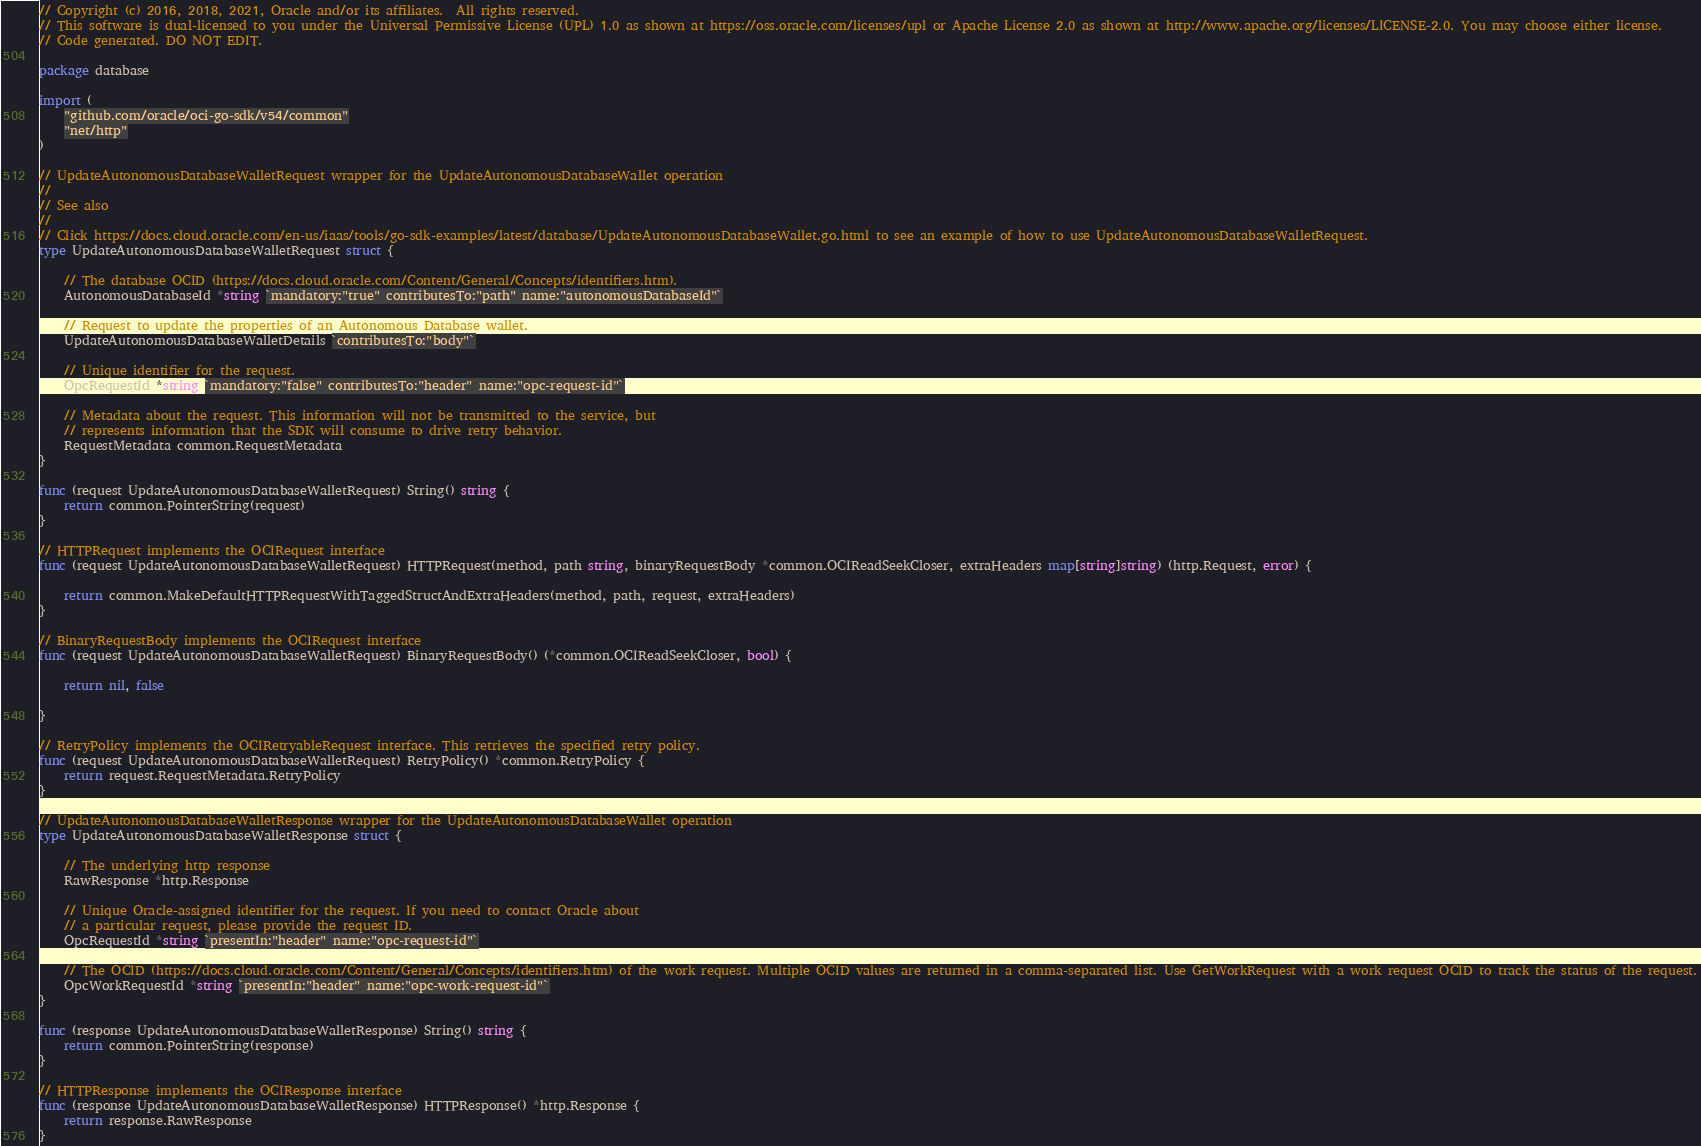Convert code to text. <code><loc_0><loc_0><loc_500><loc_500><_Go_>// Copyright (c) 2016, 2018, 2021, Oracle and/or its affiliates.  All rights reserved.
// This software is dual-licensed to you under the Universal Permissive License (UPL) 1.0 as shown at https://oss.oracle.com/licenses/upl or Apache License 2.0 as shown at http://www.apache.org/licenses/LICENSE-2.0. You may choose either license.
// Code generated. DO NOT EDIT.

package database

import (
	"github.com/oracle/oci-go-sdk/v54/common"
	"net/http"
)

// UpdateAutonomousDatabaseWalletRequest wrapper for the UpdateAutonomousDatabaseWallet operation
//
// See also
//
// Click https://docs.cloud.oracle.com/en-us/iaas/tools/go-sdk-examples/latest/database/UpdateAutonomousDatabaseWallet.go.html to see an example of how to use UpdateAutonomousDatabaseWalletRequest.
type UpdateAutonomousDatabaseWalletRequest struct {

	// The database OCID (https://docs.cloud.oracle.com/Content/General/Concepts/identifiers.htm).
	AutonomousDatabaseId *string `mandatory:"true" contributesTo:"path" name:"autonomousDatabaseId"`

	// Request to update the properties of an Autonomous Database wallet.
	UpdateAutonomousDatabaseWalletDetails `contributesTo:"body"`

	// Unique identifier for the request.
	OpcRequestId *string `mandatory:"false" contributesTo:"header" name:"opc-request-id"`

	// Metadata about the request. This information will not be transmitted to the service, but
	// represents information that the SDK will consume to drive retry behavior.
	RequestMetadata common.RequestMetadata
}

func (request UpdateAutonomousDatabaseWalletRequest) String() string {
	return common.PointerString(request)
}

// HTTPRequest implements the OCIRequest interface
func (request UpdateAutonomousDatabaseWalletRequest) HTTPRequest(method, path string, binaryRequestBody *common.OCIReadSeekCloser, extraHeaders map[string]string) (http.Request, error) {

	return common.MakeDefaultHTTPRequestWithTaggedStructAndExtraHeaders(method, path, request, extraHeaders)
}

// BinaryRequestBody implements the OCIRequest interface
func (request UpdateAutonomousDatabaseWalletRequest) BinaryRequestBody() (*common.OCIReadSeekCloser, bool) {

	return nil, false

}

// RetryPolicy implements the OCIRetryableRequest interface. This retrieves the specified retry policy.
func (request UpdateAutonomousDatabaseWalletRequest) RetryPolicy() *common.RetryPolicy {
	return request.RequestMetadata.RetryPolicy
}

// UpdateAutonomousDatabaseWalletResponse wrapper for the UpdateAutonomousDatabaseWallet operation
type UpdateAutonomousDatabaseWalletResponse struct {

	// The underlying http response
	RawResponse *http.Response

	// Unique Oracle-assigned identifier for the request. If you need to contact Oracle about
	// a particular request, please provide the request ID.
	OpcRequestId *string `presentIn:"header" name:"opc-request-id"`

	// The OCID (https://docs.cloud.oracle.com/Content/General/Concepts/identifiers.htm) of the work request. Multiple OCID values are returned in a comma-separated list. Use GetWorkRequest with a work request OCID to track the status of the request.
	OpcWorkRequestId *string `presentIn:"header" name:"opc-work-request-id"`
}

func (response UpdateAutonomousDatabaseWalletResponse) String() string {
	return common.PointerString(response)
}

// HTTPResponse implements the OCIResponse interface
func (response UpdateAutonomousDatabaseWalletResponse) HTTPResponse() *http.Response {
	return response.RawResponse
}
</code> 